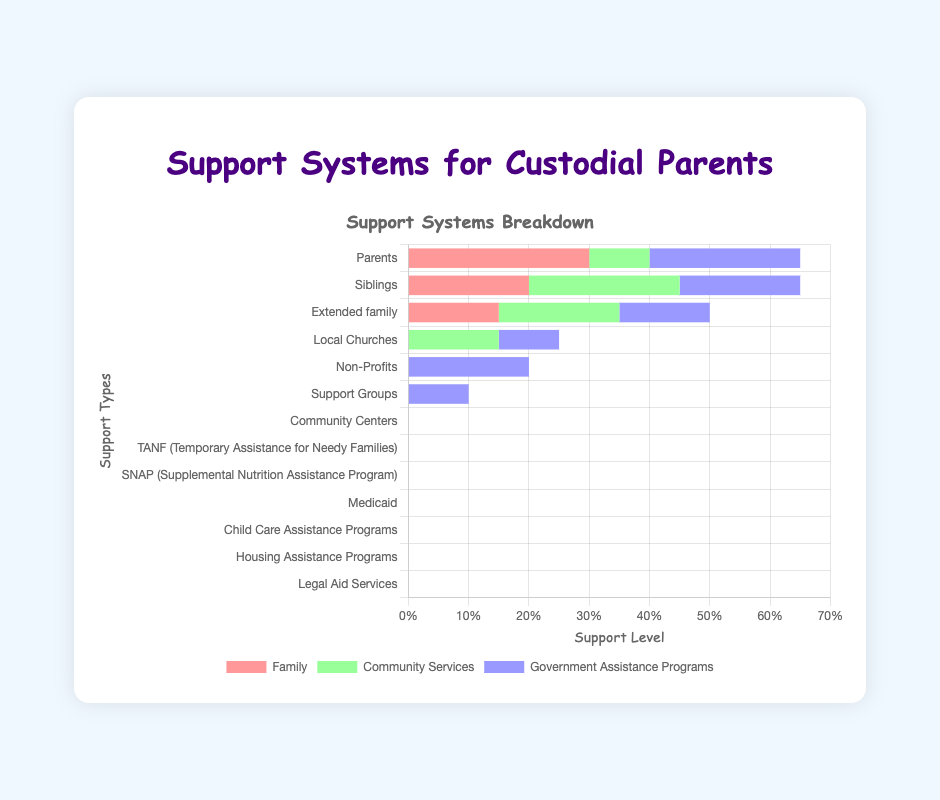Which source of support has the highest count in the government assistance programs category? To find the highest count within the government assistance programs, compare the values for each specific assistance program. TANF has 25, SNAP has 20, Medicaid has 15, Child Care Assistance Programs have 10, Housing Assistance Programs have 20, and Legal Aid Services have 10. The highest value is 25 for TANF.
Answer: TANF Overall, which source of support has the highest count across all categories? Compare the maximum values from each category. Family has Parents with 30, Community Services has Non-Profits with 25, and Government Assistance Programs has TANF with 25. The highest value is 30 for Parents.
Answer: Parents What is the combined total of support from all government assistance programs? Add the counts from all government assistance programs: TANF (25) + SNAP (20) + Medicaid (15) + Child Care Assistance Programs (10) + Housing Assistance Programs (20) + Legal Aid Services (10). The total is 25 + 20 + 15 + 10 + 20 + 10 = 100.
Answer: 100 How does the support from siblings compare to support from non-profits? Siblings provide 20 units of support, while Non-Profits provide 25 units of support. Non-Profits provide more support than Siblings.
Answer: Non-Profits provide more Is the amount of support provided by community centers greater than support provided by parents? Compare the counts: Community Centers provide 15 units, while Parents provide 30 units. Parents provide more support than Community Centers.
Answer: Parents provide more Which category offers more total support: Family or Community Services? Sum the values for each category: Family (Parents 30 + Siblings 20 + Extended Family 15 = 65) and Community Services (Local Churches 10 + Non-Profits 25 + Support Groups 20 + Community Centers 15 = 70). Compare the totals: 65 (Family) and 70 (Community Services).
Answer: Community Services What is the difference in support levels between SNAP and Medicaid? Subtract the count for Medicaid from the count for SNAP: 20 (SNAP) - 15 (Medicaid) = 5.
Answer: 5 What percentage of the total government assistance is provided by TANF? First, find the total government assistance support (100). Then, calculate TANF’s share: (25 / 100) * 100% = 25%.
Answer: 25% Are there more support services from the government or the community? Sum the support values for each category: Government (100) and Community Services (70). Compare the totals, with the government providing more at 100.
Answer: Government provides more Which has the smallest amount of support: Child Care Assistance Programs or Housing Assistance Programs? Compare the counts: Child Care Assistance Programs provide 10 units, and Housing Assistance Programs provide 20 units. Child Care Assistance Programs have the smallest amount.
Answer: Child Care Assistance Programs 